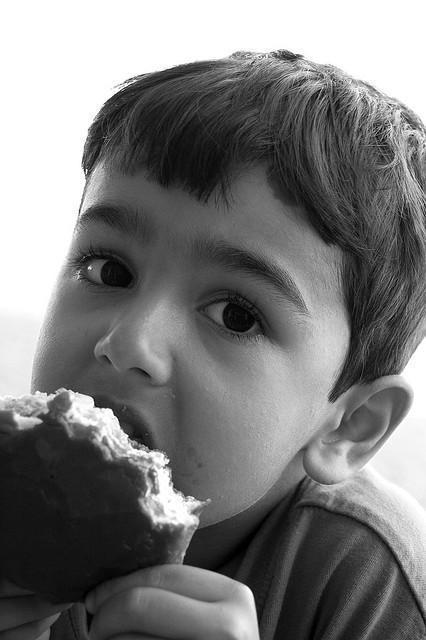Is the given caption "The person is touching the donut." fitting for the image?
Answer yes or no. Yes. Evaluate: Does the caption "The donut is in front of the person." match the image?
Answer yes or no. Yes. 